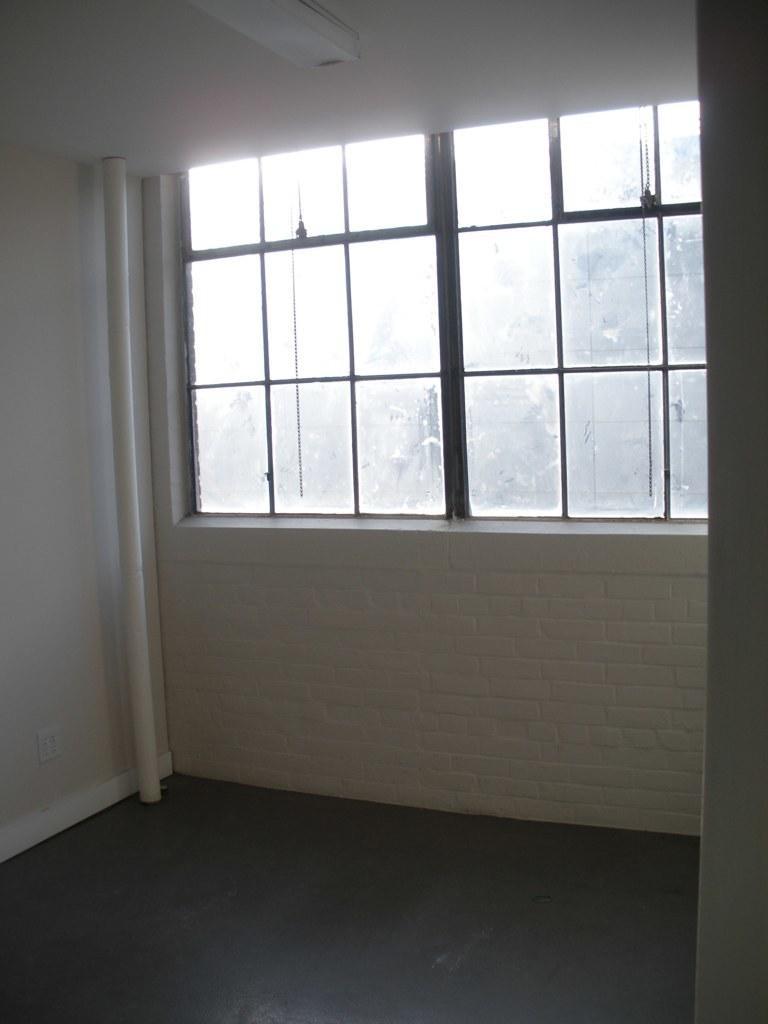Could you give a brief overview of what you see in this image? In this image I can see the interior of the room in which I can see the floor, few white colored walls, a pipe, the ceiling, a light to the ceiling and the window. 